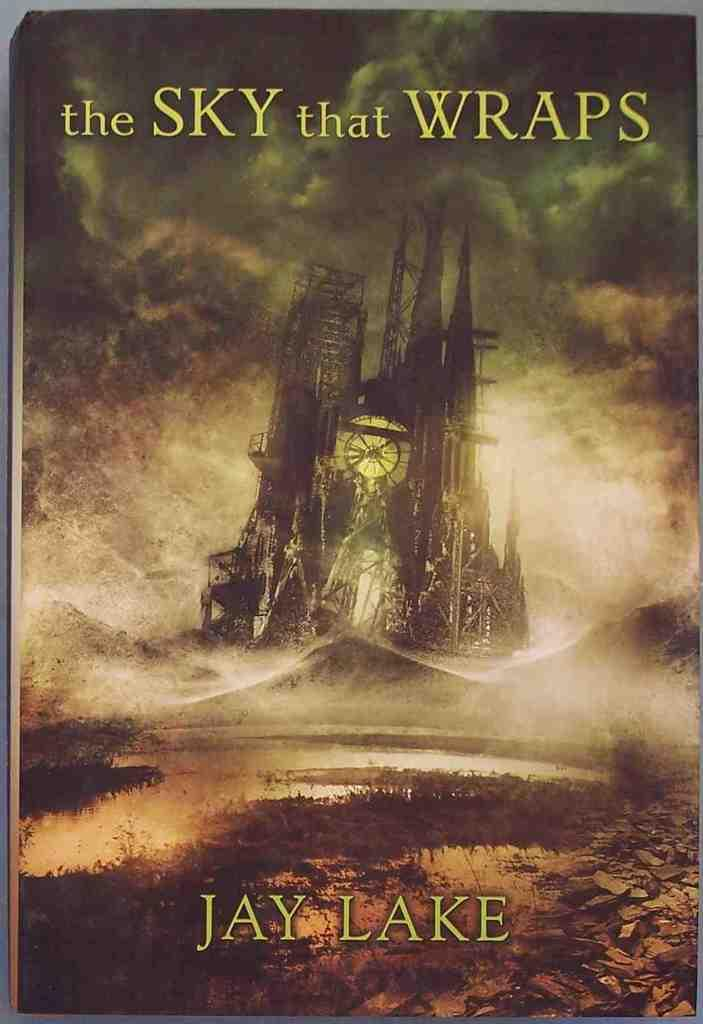<image>
Describe the image concisely. Book by Jay Lake the Sky that Wraps with a picture of a oil rig and water. 